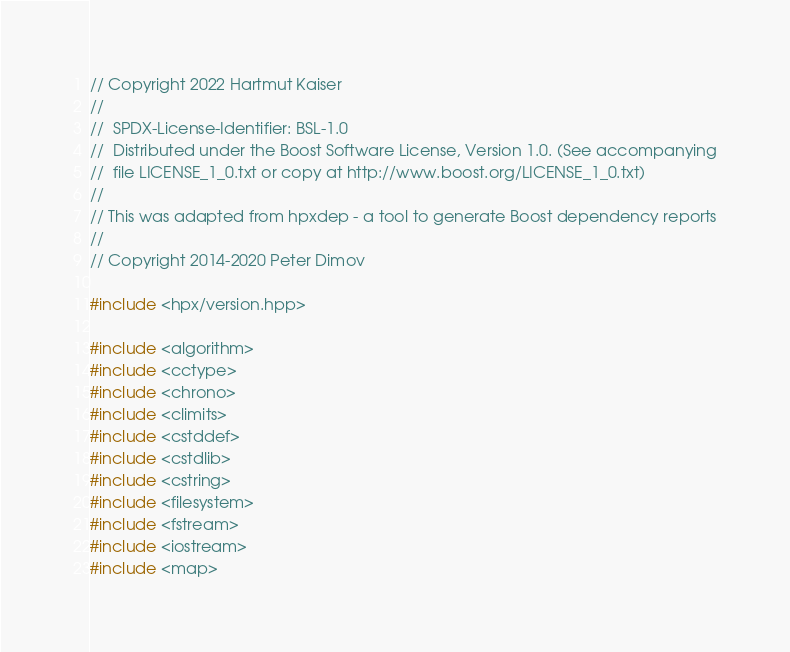<code> <loc_0><loc_0><loc_500><loc_500><_C++_>// Copyright 2022 Hartmut Kaiser
//
//  SPDX-License-Identifier: BSL-1.0
//  Distributed under the Boost Software License, Version 1.0. (See accompanying
//  file LICENSE_1_0.txt or copy at http://www.boost.org/LICENSE_1_0.txt)
//
// This was adapted from hpxdep - a tool to generate Boost dependency reports
//
// Copyright 2014-2020 Peter Dimov

#include <hpx/version.hpp>

#include <algorithm>
#include <cctype>
#include <chrono>
#include <climits>
#include <cstddef>
#include <cstdlib>
#include <cstring>
#include <filesystem>
#include <fstream>
#include <iostream>
#include <map></code> 